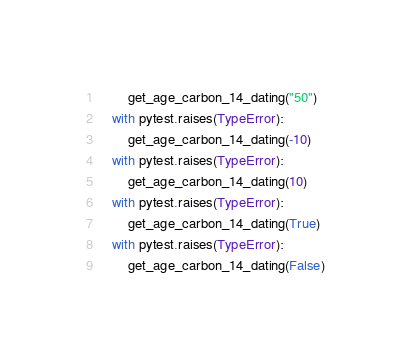<code> <loc_0><loc_0><loc_500><loc_500><_Python_>        get_age_carbon_14_dating("50")
    with pytest.raises(TypeError):
        get_age_carbon_14_dating(-10)
    with pytest.raises(TypeError):
        get_age_carbon_14_dating(10)
    with pytest.raises(TypeError):
        get_age_carbon_14_dating(True)
    with pytest.raises(TypeError):
        get_age_carbon_14_dating(False)
</code> 